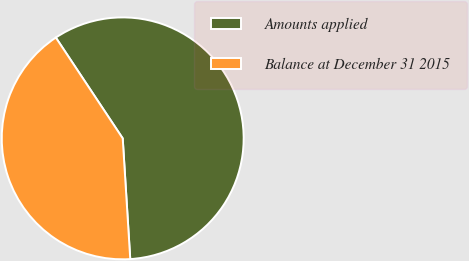Convert chart. <chart><loc_0><loc_0><loc_500><loc_500><pie_chart><fcel>Amounts applied<fcel>Balance at December 31 2015<nl><fcel>58.33%<fcel>41.67%<nl></chart> 